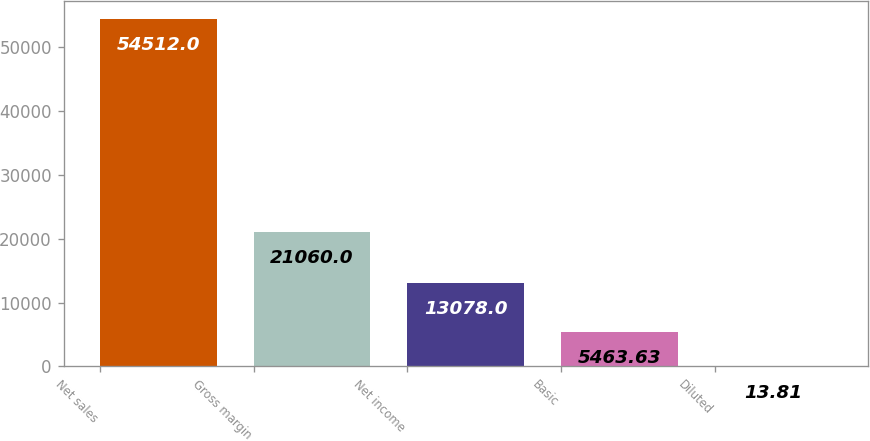Convert chart to OTSL. <chart><loc_0><loc_0><loc_500><loc_500><bar_chart><fcel>Net sales<fcel>Gross margin<fcel>Net income<fcel>Basic<fcel>Diluted<nl><fcel>54512<fcel>21060<fcel>13078<fcel>5463.63<fcel>13.81<nl></chart> 